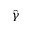<formula> <loc_0><loc_0><loc_500><loc_500>\hat { \gamma }</formula> 